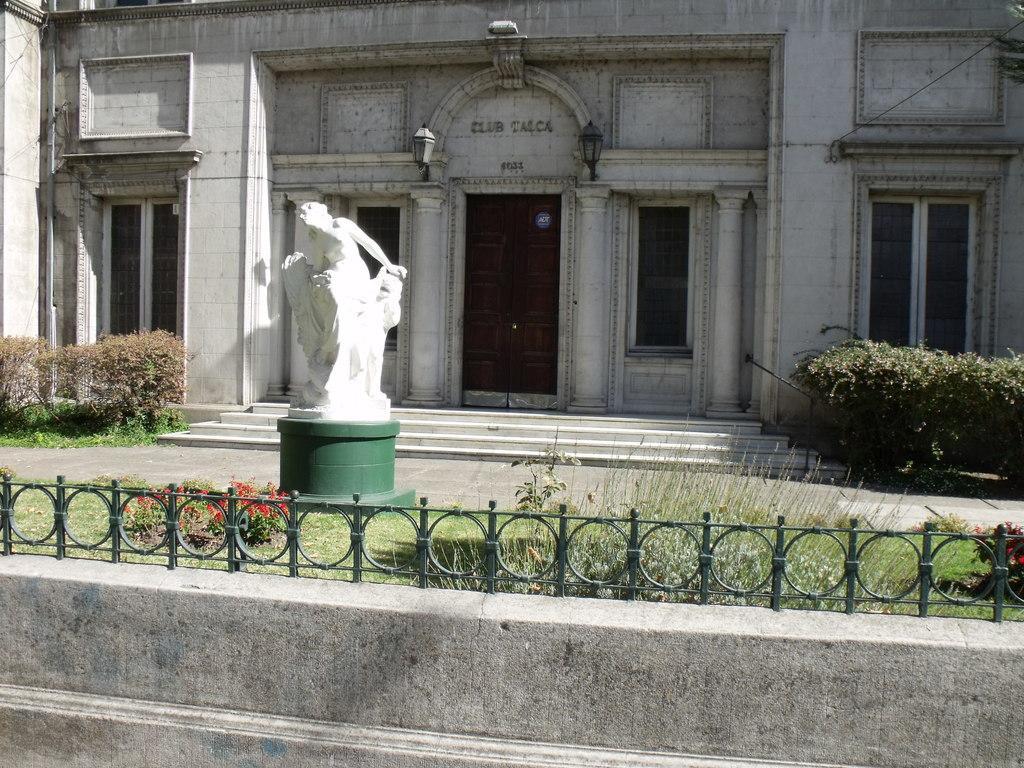Describe this image in one or two sentences. In this image we can see a statue, there is a house, door, windows, there are plants, flowers, also we can see the wall, and the railing. 